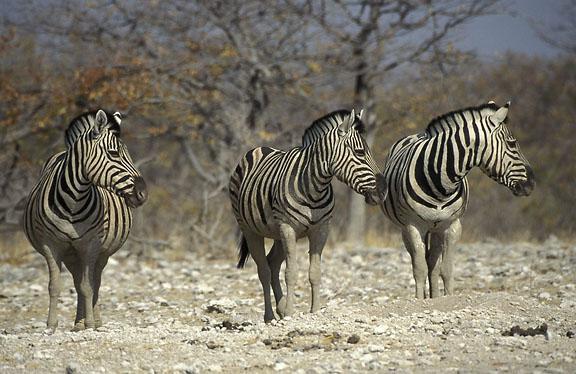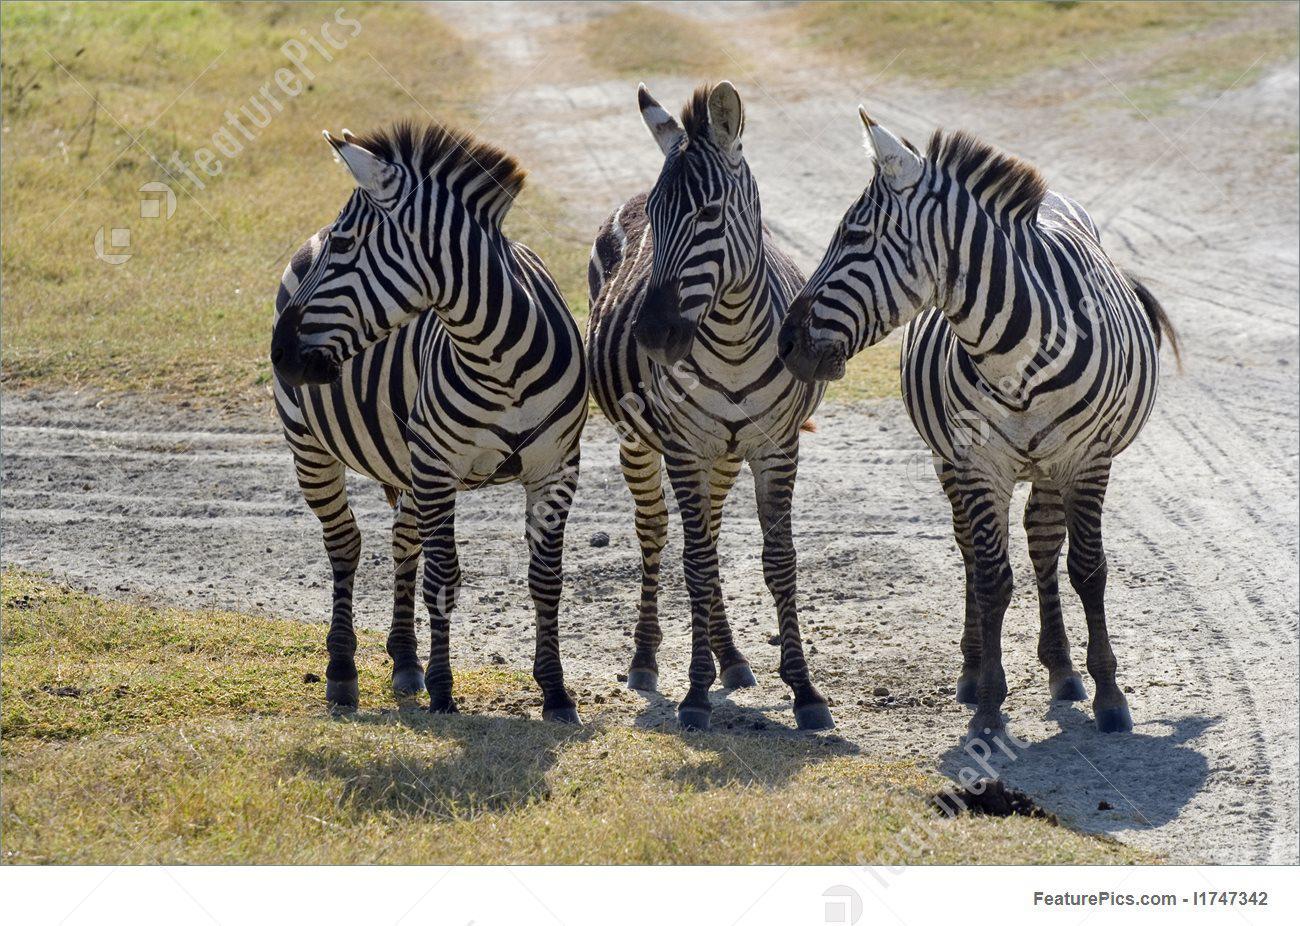The first image is the image on the left, the second image is the image on the right. Given the left and right images, does the statement "Each image contains exactly three zebras, and one group of three zebras is turned away from the camera, with their rears showing." hold true? Answer yes or no. No. 